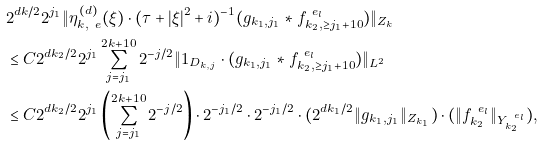Convert formula to latex. <formula><loc_0><loc_0><loc_500><loc_500>& 2 ^ { d k / 2 } 2 ^ { j _ { 1 } } \| \eta _ { k , \ e } ^ { ( d ) } ( \xi ) \cdot ( \tau + | \xi | ^ { 2 } + i ) ^ { - 1 } ( g _ { k _ { 1 } , j _ { 1 } } \ast f _ { k _ { 2 } , \geq j _ { 1 } + 1 0 } ^ { \ e _ { l } } ) \| _ { Z _ { k } } \\ & \leq C 2 ^ { d k _ { 2 } / 2 } 2 ^ { j _ { 1 } } \sum _ { j = j _ { 1 } } ^ { 2 k + 1 0 } 2 ^ { - j / 2 } \| 1 _ { D _ { k , j } } \cdot ( g _ { k _ { 1 } , j _ { 1 } } \ast f _ { k _ { 2 } , \geq j _ { 1 } + 1 0 } ^ { \ e _ { l } } ) \| _ { L ^ { 2 } } \\ & \leq C 2 ^ { d k _ { 2 } / 2 } 2 ^ { j _ { 1 } } \left ( \sum _ { j = j _ { 1 } } ^ { 2 k + 1 0 } 2 ^ { - j / 2 } \right ) \cdot 2 ^ { - j _ { 1 } / 2 } \cdot 2 ^ { - j _ { 1 } / 2 } \cdot ( 2 ^ { d k _ { 1 } / 2 } \| g _ { k _ { 1 } , j _ { 1 } } \| _ { Z _ { k _ { 1 } } } ) \cdot ( \| f _ { k _ { 2 } } ^ { \ e _ { l } } \| _ { Y _ { k _ { 2 } } ^ { \ e _ { l } } } ) ,</formula> 